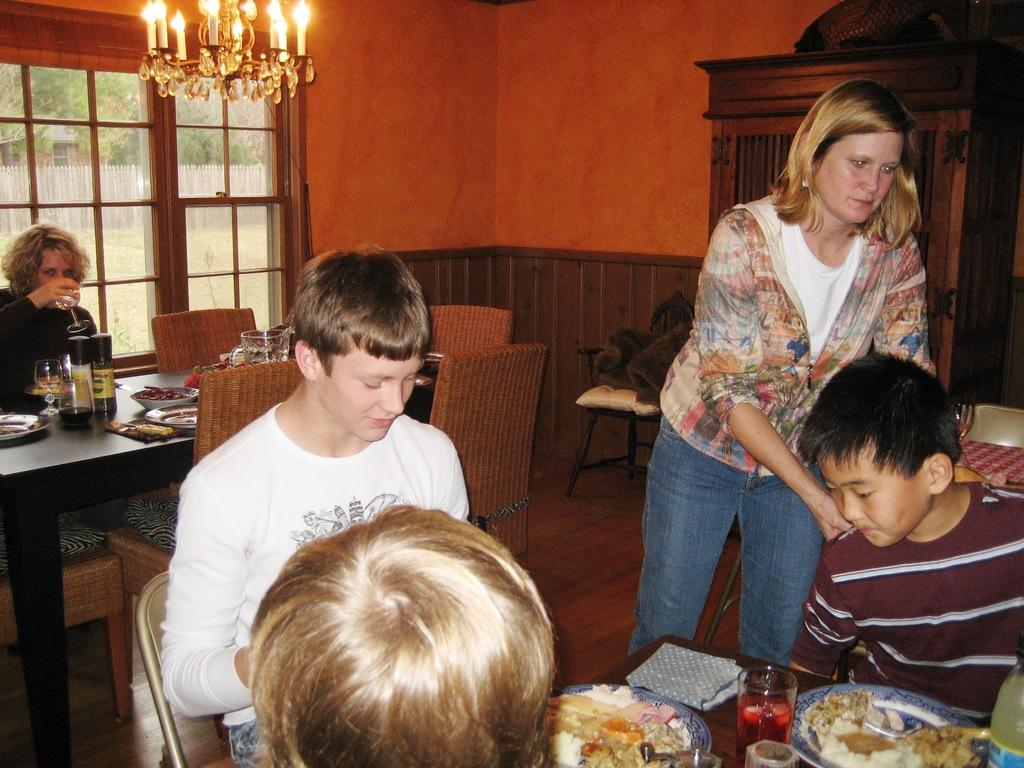What type of setting is shown in the image? The image depicts a restaurant setting. What are the people in the image doing? The people are seated in the restaurant and eating food from plates on a table. Can you describe the woman in the image? There is a woman standing in the image. How many ducks are jumping over the bridge in the image? There are no ducks or bridges present in the image. 